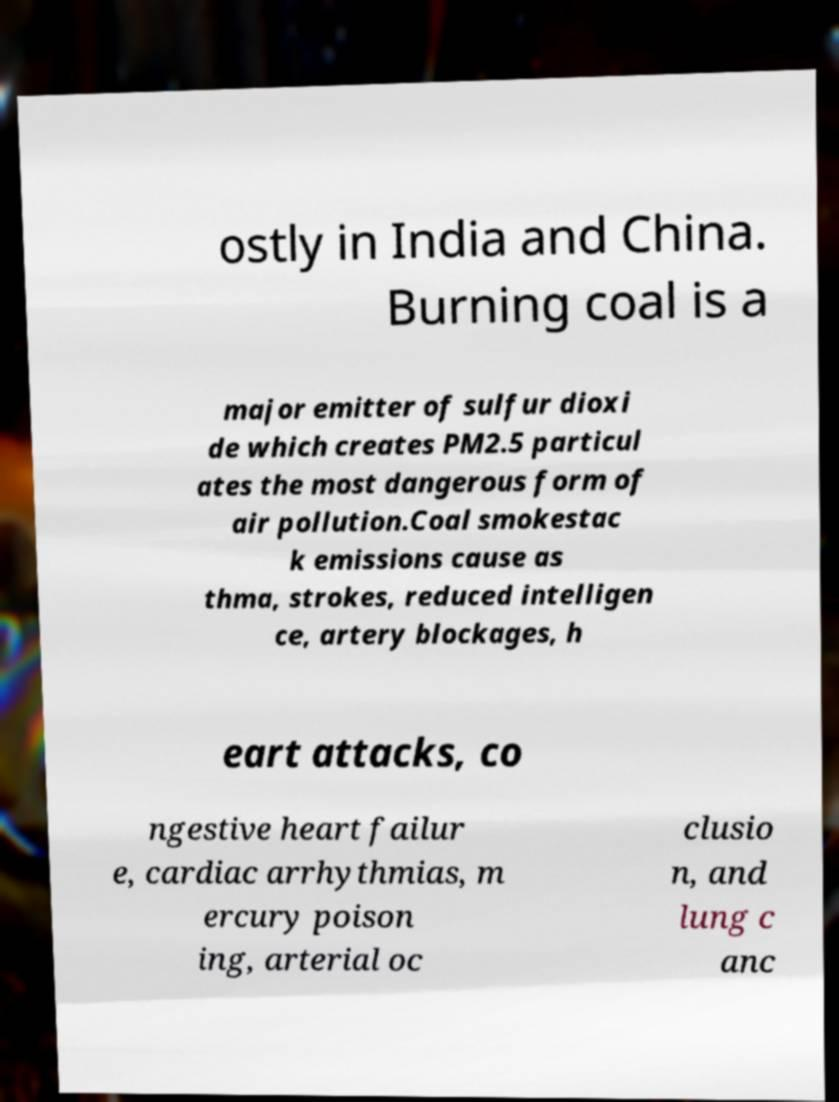What messages or text are displayed in this image? I need them in a readable, typed format. ostly in India and China. Burning coal is a major emitter of sulfur dioxi de which creates PM2.5 particul ates the most dangerous form of air pollution.Coal smokestac k emissions cause as thma, strokes, reduced intelligen ce, artery blockages, h eart attacks, co ngestive heart failur e, cardiac arrhythmias, m ercury poison ing, arterial oc clusio n, and lung c anc 